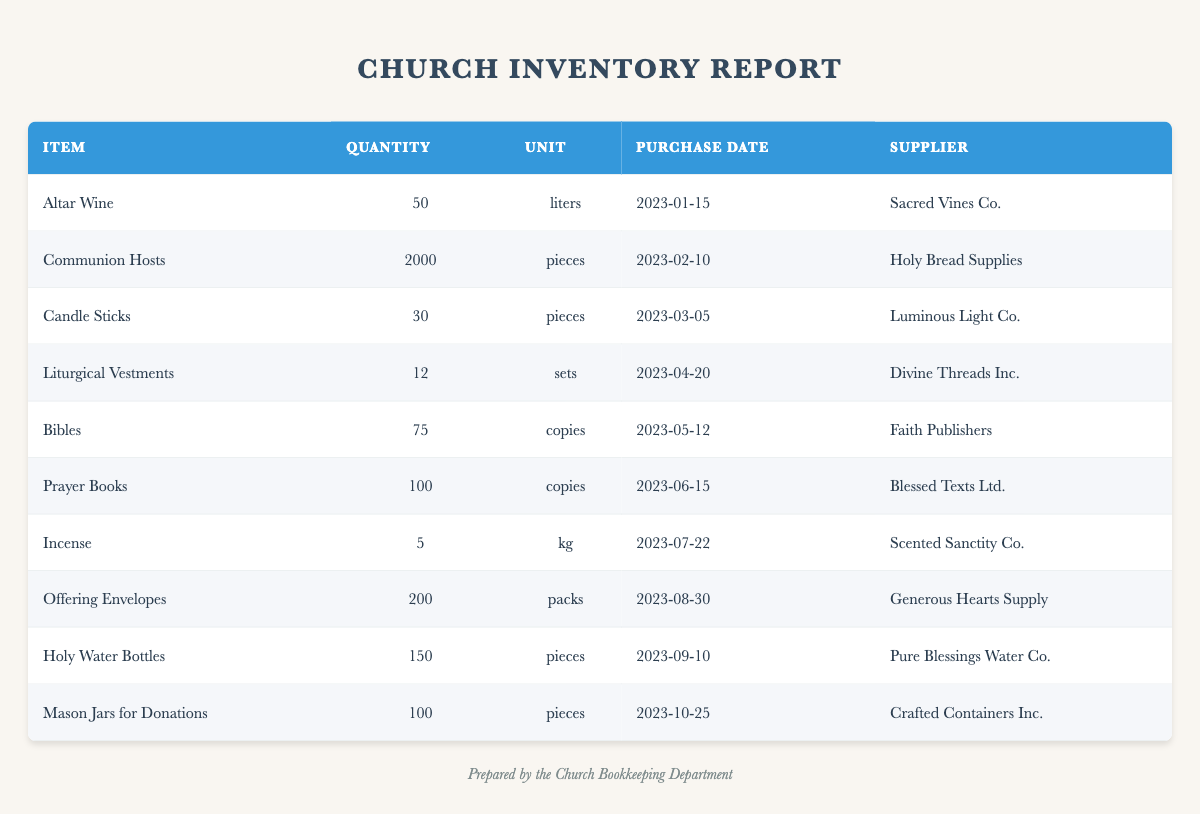What was the quantity of Communion Hosts purchased? The table shows that Communion Hosts were purchased with a quantity of 2000 pieces.
Answer: 2000 pieces Who is the supplier for Holy Water Bottles? According to the table, the supplier listed for Holy Water Bottles is Pure Blessings Water Co.
Answer: Pure Blessings Water Co How many items were purchased after June 15, 2023? Looking at the purchase dates, the following items were purchased after June 15, 2023: Incense, Offering Envelopes, Holy Water Bottles, and Mason Jars for Donations. This totals to 4 items.
Answer: 4 items What is the total quantity of all the items in the inventory? To find the total quantity, I will sum the quantities of each item: 50 + 2000 + 30 + 12 + 75 + 100 + 5 + 200 + 150 + 100 = 2672. Therefore, the total quantity is 2672.
Answer: 2672 Did the church purchase any Altar Wine in March? The table indicates that Altar Wine was purchased on January 15, 2023, and no Altar Wine was purchased in March, making this statement false.
Answer: No What is the average quantity of pieces purchased for items categorized by pieces? The items categorized by pieces are Communion Hosts (2000), Candle Sticks (30), Offering Envelopes (200), Holy Water Bottles (150), and Mason Jars for Donations (100). Their sum is 2000 + 30 + 200 + 150 + 100 = 2480, and there are 5 items. The average is 2480/5 = 496.
Answer: 496 Which item had the latest purchase date? Reviewing the purchase dates, Mason Jars for Donations were purchased on October 25, 2023, which is later than any other item in the table.
Answer: Mason Jars for Donations Is the quantity of Prayer Books greater than the quantity of Candle Sticks? Prayer Books has a quantity of 100, while Candle Sticks has a quantity of 30. Since 100 is greater than 30, this statement is true.
Answer: Yes How many items were purchased from Divine Threads Inc.? The table lists one item purchased from Divine Threads Inc., which is Liturgical Vestments.
Answer: 1 item 